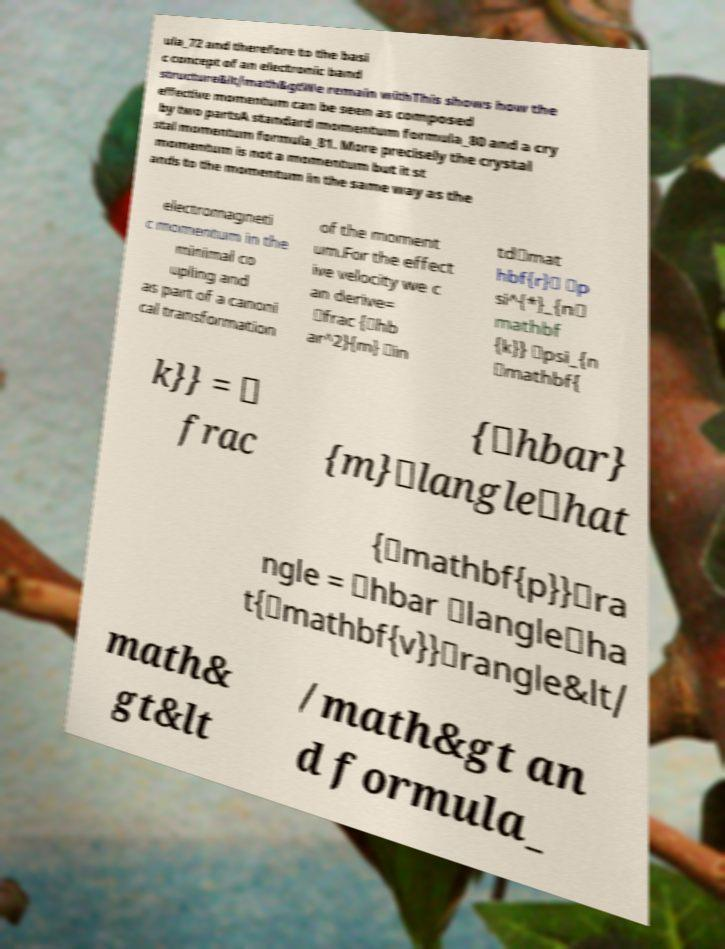Could you extract and type out the text from this image? ula_72 and therefore to the basi c concept of an electronic band structure&lt/math&gtWe remain withThis shows how the effective momentum can be seen as composed by two partsA standard momentum formula_80 and a cry stal momentum formula_81. More precisely the crystal momentum is not a momentum but it st ands to the momentum in the same way as the electromagneti c momentum in the minimal co upling and as part of a canoni cal transformation of the moment um.For the effect ive velocity we c an derive= \frac {\hb ar^2}{m} \in td\mat hbf{r}\ \p si^{*}_{n\ mathbf {k}} \psi_{n \mathbf{ k}} = \ frac {\hbar} {m}\langle\hat {\mathbf{p}}\ra ngle = \hbar \langle\ha t{\mathbf{v}}\rangle&lt/ math& gt&lt /math&gt an d formula_ 